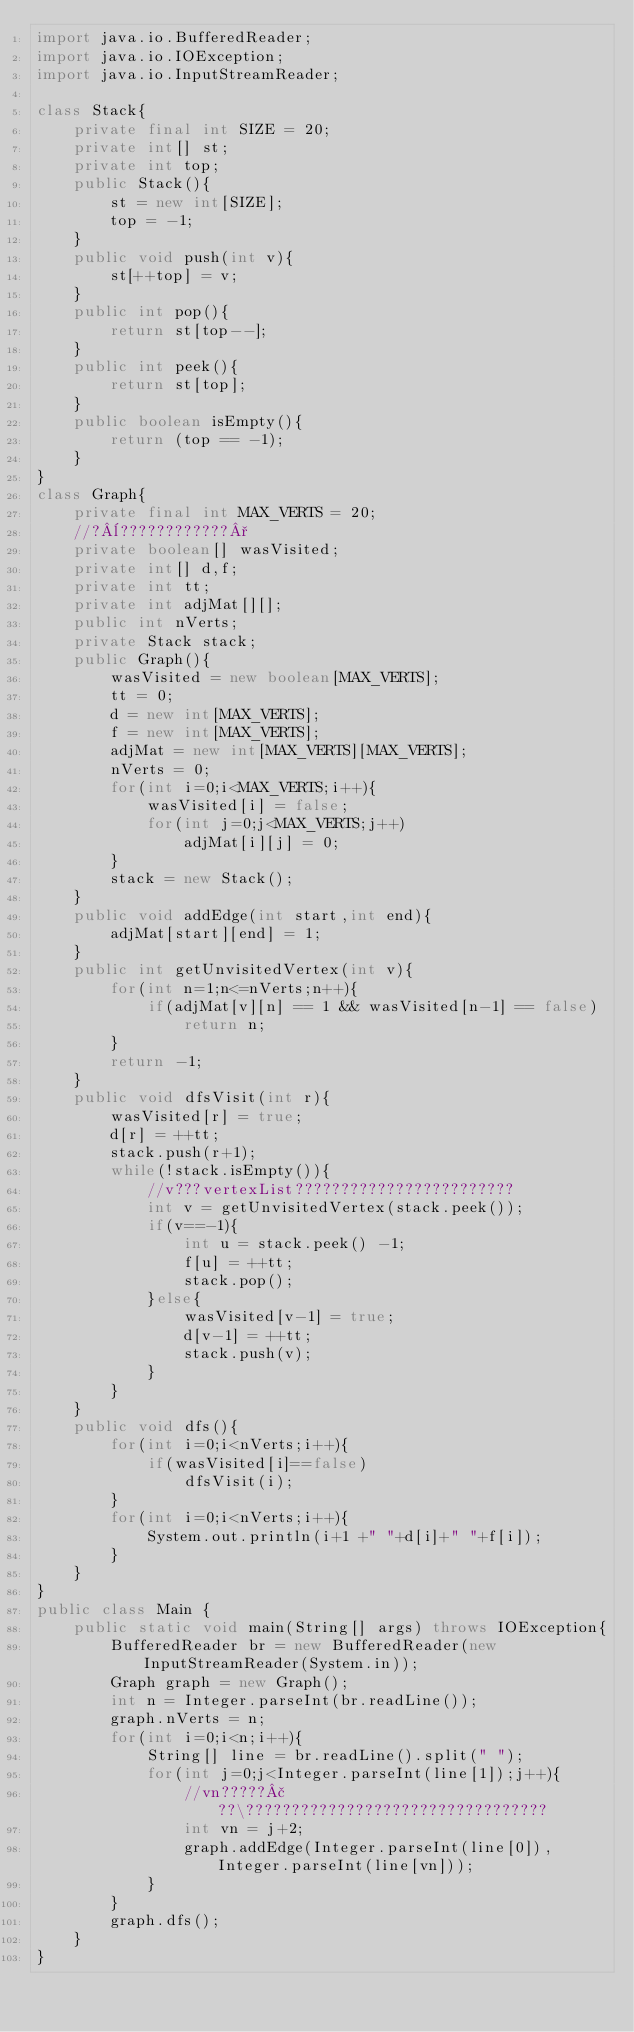Convert code to text. <code><loc_0><loc_0><loc_500><loc_500><_Java_>import java.io.BufferedReader;
import java.io.IOException;
import java.io.InputStreamReader;

class Stack{
	private final int SIZE = 20;
	private int[] st;
	private int top;
	public Stack(){
		st = new int[SIZE];
		top = -1;
	}
	public void push(int v){
		st[++top] = v;
	}
	public int pop(){
		return st[top--];
	}
	public int peek(){
		return st[top];
	}
	public boolean isEmpty(){
		return (top == -1);
	}
}
class Graph{
	private final int MAX_VERTS = 20;
	//?¨????????????°
	private boolean[] wasVisited;
	private int[] d,f;
	private int tt;
	private int adjMat[][];
	public int nVerts;
	private Stack stack;
	public Graph(){
		wasVisited = new boolean[MAX_VERTS];
		tt = 0;
		d = new int[MAX_VERTS];
		f = new int[MAX_VERTS];
		adjMat = new int[MAX_VERTS][MAX_VERTS];
		nVerts = 0;
		for(int i=0;i<MAX_VERTS;i++){
			wasVisited[i] = false;
			for(int j=0;j<MAX_VERTS;j++)
				adjMat[i][j] = 0;
		}
		stack = new Stack();
	}
	public void addEdge(int start,int end){
		adjMat[start][end] = 1;
	}
	public int getUnvisitedVertex(int v){
		for(int n=1;n<=nVerts;n++){
			if(adjMat[v][n] == 1 && wasVisited[n-1] == false)
				return n;
		}
		return -1;
	}
	public void dfsVisit(int r){
		wasVisited[r] = true;
		d[r] = ++tt;
		stack.push(r+1);
		while(!stack.isEmpty()){
			//v???vertexList????????????????????????
			int v = getUnvisitedVertex(stack.peek());
			if(v==-1){
				int u = stack.peek() -1;
				f[u] = ++tt;
				stack.pop();
			}else{
				wasVisited[v-1] = true;
				d[v-1] = ++tt;
				stack.push(v);
			}
		}
	}
	public void dfs(){
		for(int i=0;i<nVerts;i++){
			if(wasVisited[i]==false)
				dfsVisit(i);
		}
		for(int i=0;i<nVerts;i++){
			System.out.println(i+1 +" "+d[i]+" "+f[i]);
		}
	}
}
public class Main {
	public static void main(String[] args) throws IOException{
		BufferedReader br = new BufferedReader(new InputStreamReader(System.in));
		Graph graph = new Graph();
		int n = Integer.parseInt(br.readLine());
		graph.nVerts = n;
		for(int i=0;i<n;i++){
			String[] line = br.readLine().split(" ");
			for(int j=0;j<Integer.parseInt(line[1]);j++){
				//vn?????£??\?????????????????????????????????
				int vn = j+2;
				graph.addEdge(Integer.parseInt(line[0]), Integer.parseInt(line[vn]));
			}
		}
		graph.dfs();
	}
}</code> 